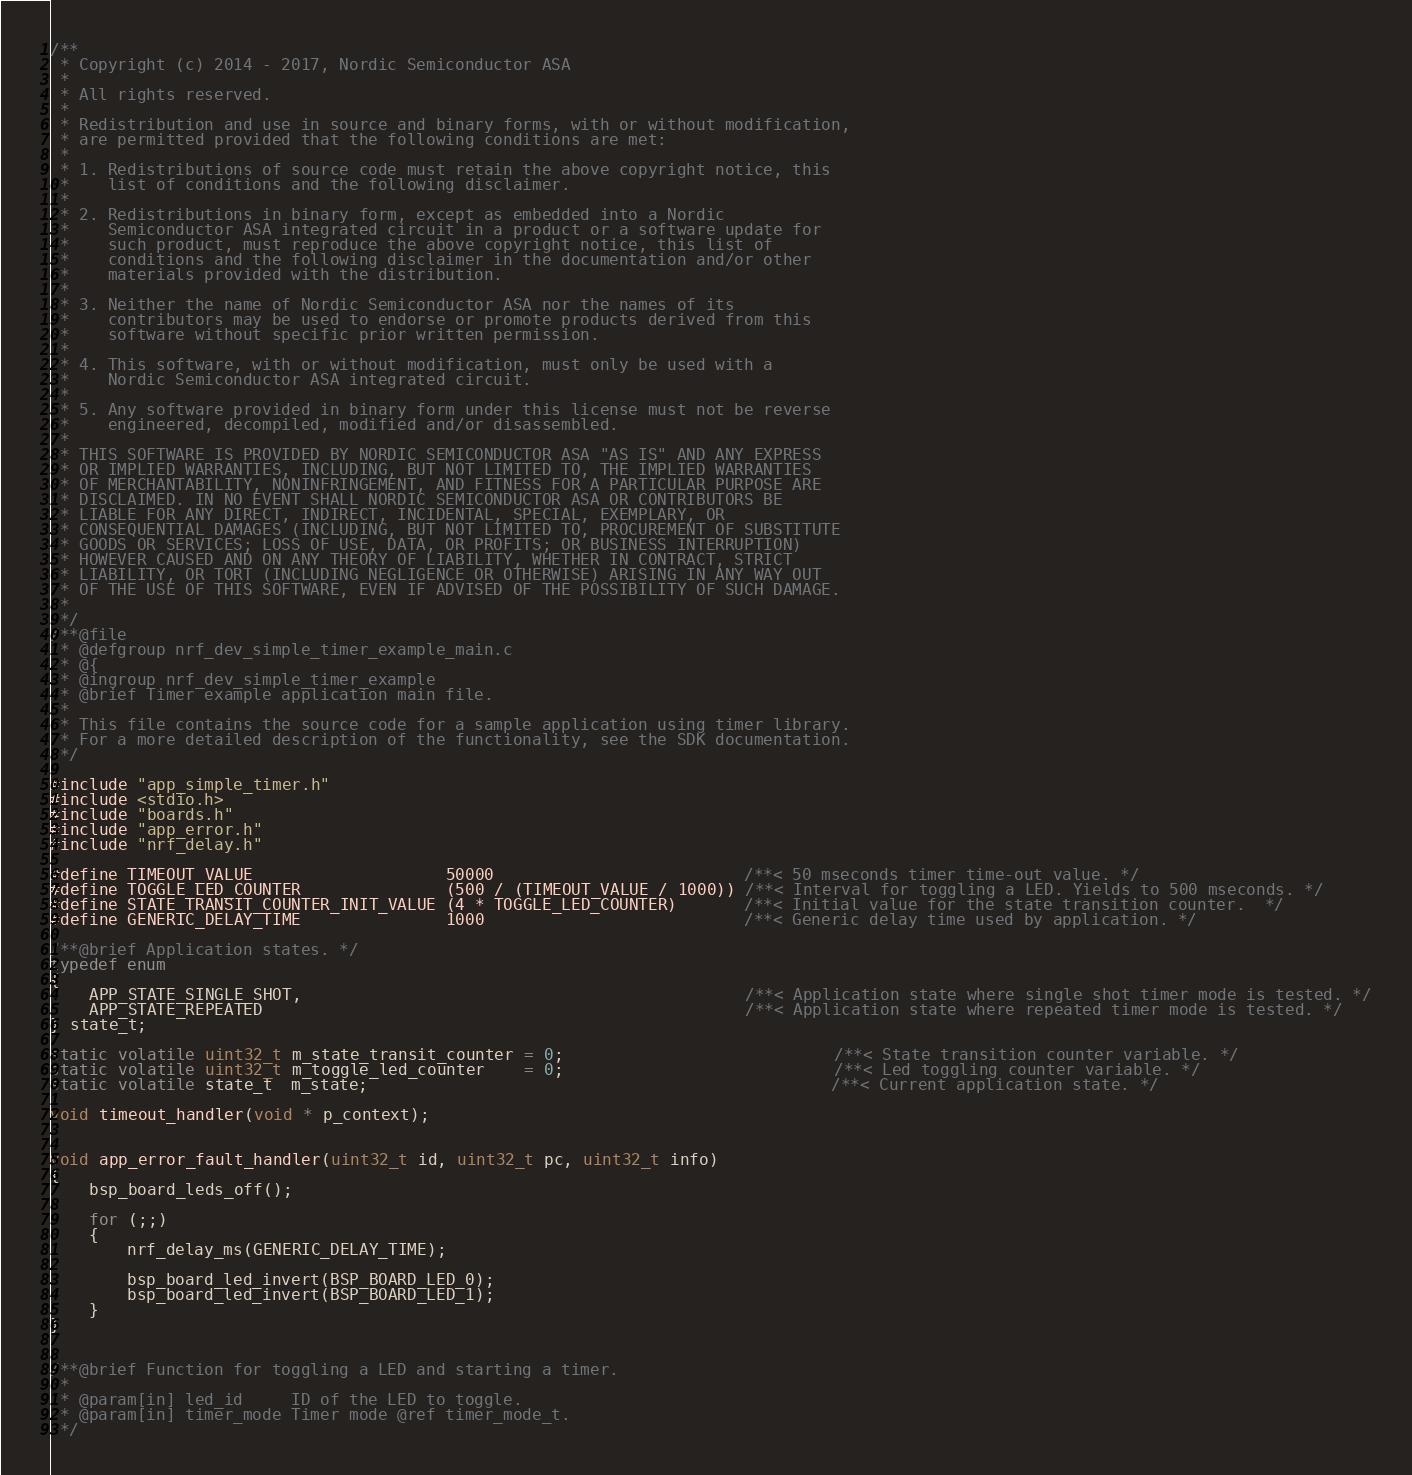<code> <loc_0><loc_0><loc_500><loc_500><_C_>/**
 * Copyright (c) 2014 - 2017, Nordic Semiconductor ASA
 * 
 * All rights reserved.
 * 
 * Redistribution and use in source and binary forms, with or without modification,
 * are permitted provided that the following conditions are met:
 * 
 * 1. Redistributions of source code must retain the above copyright notice, this
 *    list of conditions and the following disclaimer.
 * 
 * 2. Redistributions in binary form, except as embedded into a Nordic
 *    Semiconductor ASA integrated circuit in a product or a software update for
 *    such product, must reproduce the above copyright notice, this list of
 *    conditions and the following disclaimer in the documentation and/or other
 *    materials provided with the distribution.
 * 
 * 3. Neither the name of Nordic Semiconductor ASA nor the names of its
 *    contributors may be used to endorse or promote products derived from this
 *    software without specific prior written permission.
 * 
 * 4. This software, with or without modification, must only be used with a
 *    Nordic Semiconductor ASA integrated circuit.
 * 
 * 5. Any software provided in binary form under this license must not be reverse
 *    engineered, decompiled, modified and/or disassembled.
 * 
 * THIS SOFTWARE IS PROVIDED BY NORDIC SEMICONDUCTOR ASA "AS IS" AND ANY EXPRESS
 * OR IMPLIED WARRANTIES, INCLUDING, BUT NOT LIMITED TO, THE IMPLIED WARRANTIES
 * OF MERCHANTABILITY, NONINFRINGEMENT, AND FITNESS FOR A PARTICULAR PURPOSE ARE
 * DISCLAIMED. IN NO EVENT SHALL NORDIC SEMICONDUCTOR ASA OR CONTRIBUTORS BE
 * LIABLE FOR ANY DIRECT, INDIRECT, INCIDENTAL, SPECIAL, EXEMPLARY, OR
 * CONSEQUENTIAL DAMAGES (INCLUDING, BUT NOT LIMITED TO, PROCUREMENT OF SUBSTITUTE
 * GOODS OR SERVICES; LOSS OF USE, DATA, OR PROFITS; OR BUSINESS INTERRUPTION)
 * HOWEVER CAUSED AND ON ANY THEORY OF LIABILITY, WHETHER IN CONTRACT, STRICT
 * LIABILITY, OR TORT (INCLUDING NEGLIGENCE OR OTHERWISE) ARISING IN ANY WAY OUT
 * OF THE USE OF THIS SOFTWARE, EVEN IF ADVISED OF THE POSSIBILITY OF SUCH DAMAGE.
 * 
 */
/**@file
 * @defgroup nrf_dev_simple_timer_example_main.c
 * @{
 * @ingroup nrf_dev_simple_timer_example
 * @brief Timer example application main file.
 *
 * This file contains the source code for a sample application using timer library.
 * For a more detailed description of the functionality, see the SDK documentation.
 */

#include "app_simple_timer.h"
#include <stdio.h>
#include "boards.h"
#include "app_error.h"
#include "nrf_delay.h"

#define TIMEOUT_VALUE                    50000                          /**< 50 mseconds timer time-out value. */
#define TOGGLE_LED_COUNTER               (500 / (TIMEOUT_VALUE / 1000)) /**< Interval for toggling a LED. Yields to 500 mseconds. */
#define STATE_TRANSIT_COUNTER_INIT_VALUE (4 * TOGGLE_LED_COUNTER)       /**< Initial value for the state transition counter.  */
#define GENERIC_DELAY_TIME               1000                           /**< Generic delay time used by application. */

/**@brief Application states. */
typedef enum
{
    APP_STATE_SINGLE_SHOT,                                              /**< Application state where single shot timer mode is tested. */
    APP_STATE_REPEATED                                                  /**< Application state where repeated timer mode is tested. */
} state_t;

static volatile uint32_t m_state_transit_counter = 0;                            /**< State transition counter variable. */
static volatile uint32_t m_toggle_led_counter    = 0;                            /**< Led toggling counter variable. */
static volatile state_t  m_state;                                                /**< Current application state. */

void timeout_handler(void * p_context);


void app_error_fault_handler(uint32_t id, uint32_t pc, uint32_t info)
{
    bsp_board_leds_off();

    for (;;)
    {
        nrf_delay_ms(GENERIC_DELAY_TIME);

        bsp_board_led_invert(BSP_BOARD_LED_0);
        bsp_board_led_invert(BSP_BOARD_LED_1);
    }
}


/**@brief Function for toggling a LED and starting a timer.
 *
 * @param[in] led_id     ID of the LED to toggle.
 * @param[in] timer_mode Timer mode @ref timer_mode_t.
 */</code> 